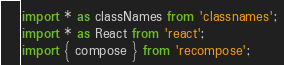Convert code to text. <code><loc_0><loc_0><loc_500><loc_500><_TypeScript_>import * as classNames from 'classnames';
import * as React from 'react';
import { compose } from 'recompose';</code> 